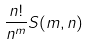Convert formula to latex. <formula><loc_0><loc_0><loc_500><loc_500>\frac { n ! } { n ^ { m } } S ( m , n )</formula> 